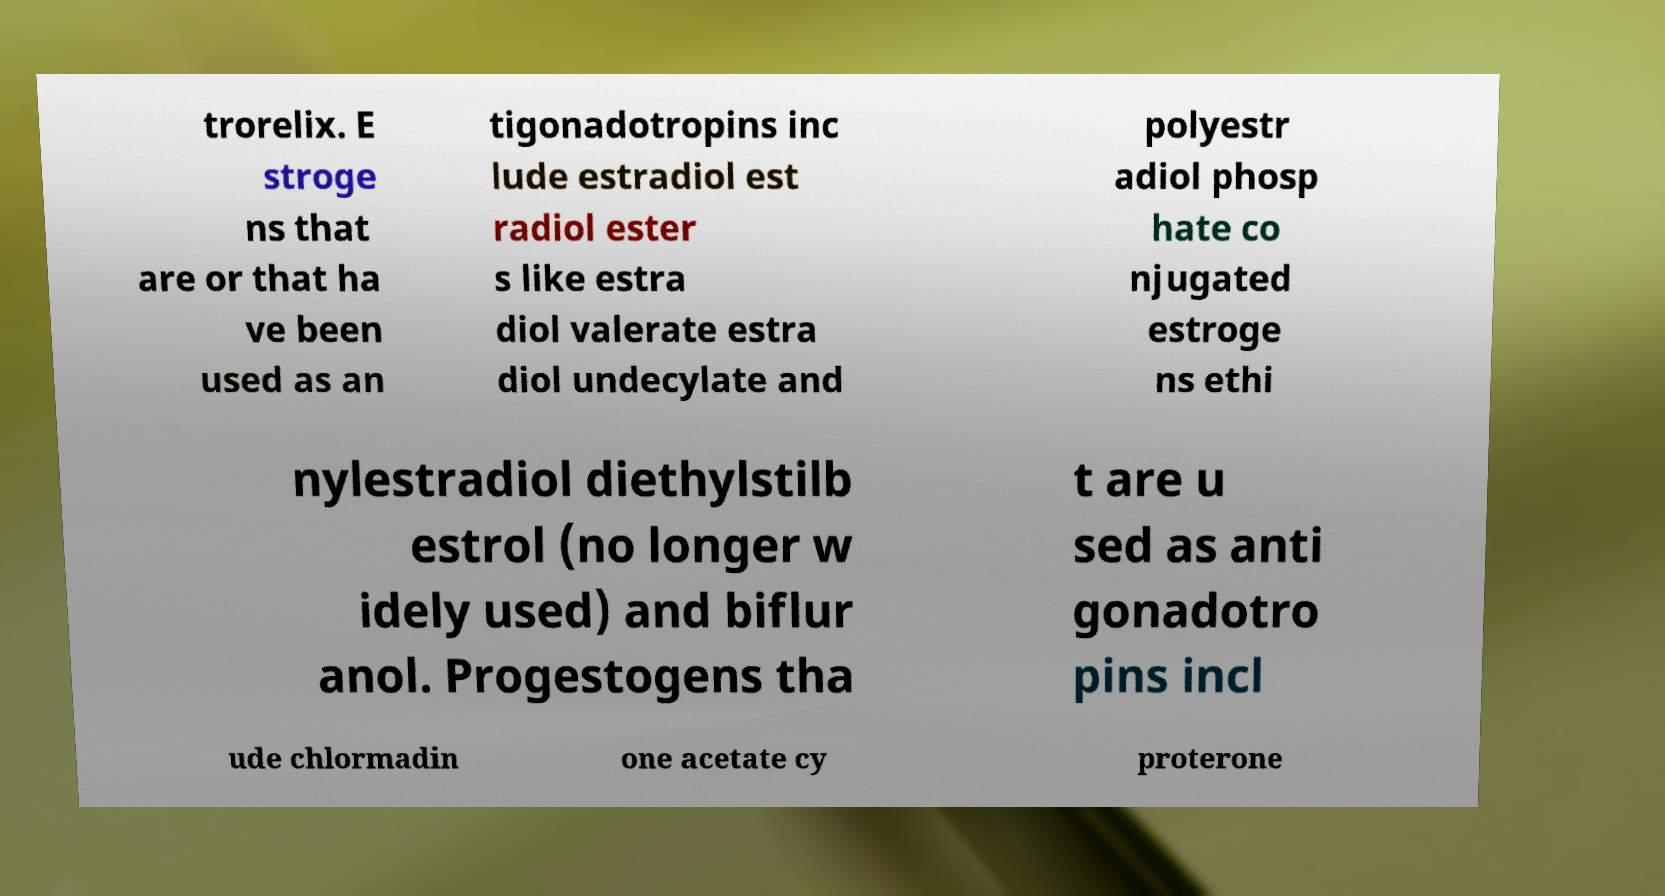Could you assist in decoding the text presented in this image and type it out clearly? trorelix. E stroge ns that are or that ha ve been used as an tigonadotropins inc lude estradiol est radiol ester s like estra diol valerate estra diol undecylate and polyestr adiol phosp hate co njugated estroge ns ethi nylestradiol diethylstilb estrol (no longer w idely used) and biflur anol. Progestogens tha t are u sed as anti gonadotro pins incl ude chlormadin one acetate cy proterone 